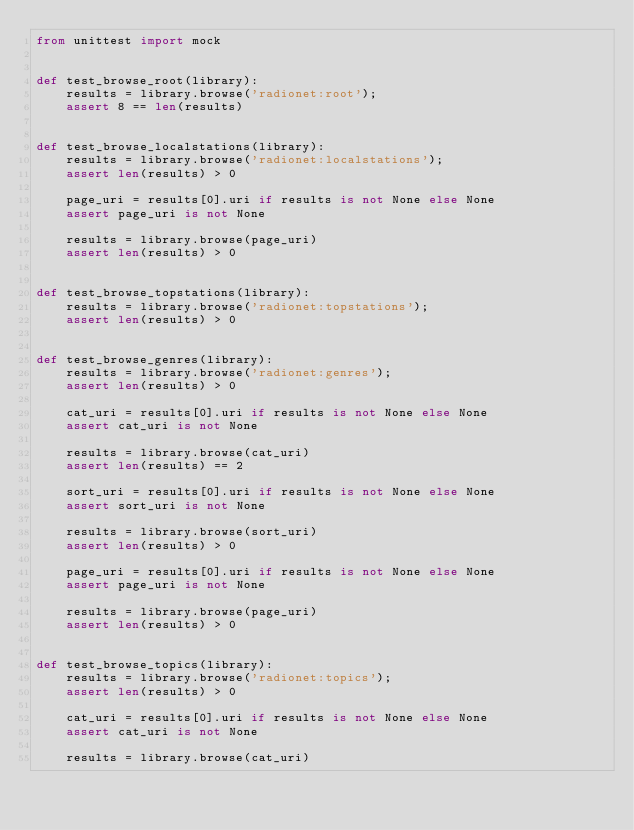<code> <loc_0><loc_0><loc_500><loc_500><_Python_>from unittest import mock


def test_browse_root(library):
    results = library.browse('radionet:root');
    assert 8 == len(results)


def test_browse_localstations(library):
    results = library.browse('radionet:localstations');
    assert len(results) > 0

    page_uri = results[0].uri if results is not None else None
    assert page_uri is not None

    results = library.browse(page_uri)
    assert len(results) > 0


def test_browse_topstations(library):
    results = library.browse('radionet:topstations');
    assert len(results) > 0


def test_browse_genres(library):
    results = library.browse('radionet:genres');
    assert len(results) > 0

    cat_uri = results[0].uri if results is not None else None
    assert cat_uri is not None

    results = library.browse(cat_uri)
    assert len(results) == 2

    sort_uri = results[0].uri if results is not None else None
    assert sort_uri is not None

    results = library.browse(sort_uri)
    assert len(results) > 0

    page_uri = results[0].uri if results is not None else None
    assert page_uri is not None

    results = library.browse(page_uri)
    assert len(results) > 0


def test_browse_topics(library):
    results = library.browse('radionet:topics');
    assert len(results) > 0

    cat_uri = results[0].uri if results is not None else None
    assert cat_uri is not None

    results = library.browse(cat_uri)</code> 